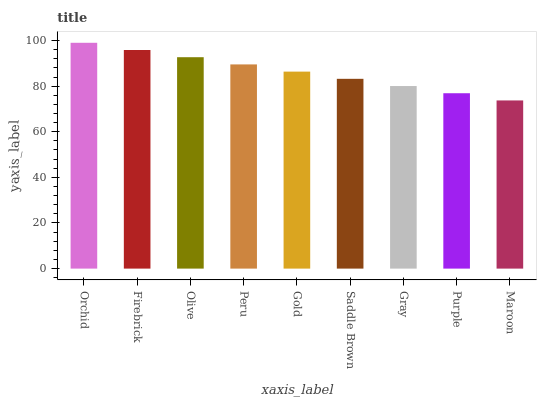Is Firebrick the minimum?
Answer yes or no. No. Is Firebrick the maximum?
Answer yes or no. No. Is Orchid greater than Firebrick?
Answer yes or no. Yes. Is Firebrick less than Orchid?
Answer yes or no. Yes. Is Firebrick greater than Orchid?
Answer yes or no. No. Is Orchid less than Firebrick?
Answer yes or no. No. Is Gold the high median?
Answer yes or no. Yes. Is Gold the low median?
Answer yes or no. Yes. Is Maroon the high median?
Answer yes or no. No. Is Firebrick the low median?
Answer yes or no. No. 